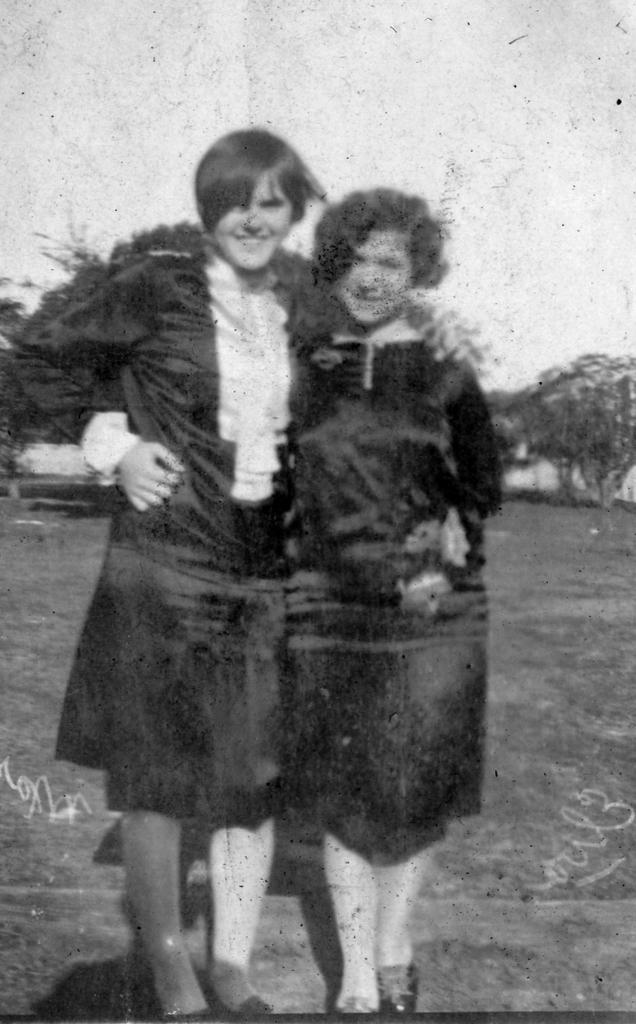How many people are present in the image? There are two people standing in the image. What can be seen in the background of the image? Trees are visible in the background of the image, and there might be a building as well. What is visible at the top of the image? The sky is visible at the top of the image. What might be present at the bottom of the image? There might be grass at the bottom of the image. What type of linen is being used by the father in the image? There is no father present in the image, and no linen is visible. What historical event is being commemorated in the image? There is no indication of a historical event being commemorated in the image. 